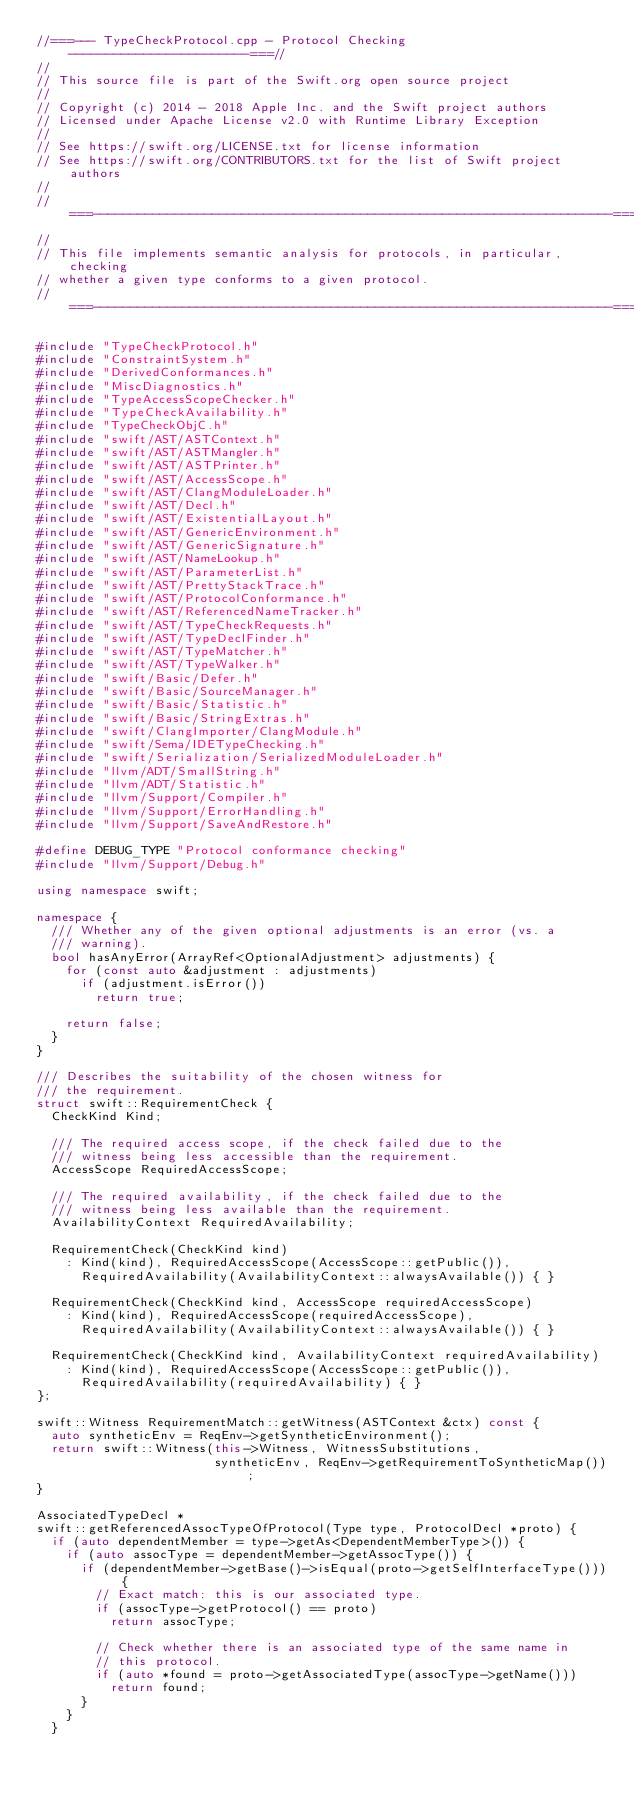<code> <loc_0><loc_0><loc_500><loc_500><_C++_>//===--- TypeCheckProtocol.cpp - Protocol Checking ------------------------===//
//
// This source file is part of the Swift.org open source project
//
// Copyright (c) 2014 - 2018 Apple Inc. and the Swift project authors
// Licensed under Apache License v2.0 with Runtime Library Exception
//
// See https://swift.org/LICENSE.txt for license information
// See https://swift.org/CONTRIBUTORS.txt for the list of Swift project authors
//
//===----------------------------------------------------------------------===//
//
// This file implements semantic analysis for protocols, in particular, checking
// whether a given type conforms to a given protocol.
//===----------------------------------------------------------------------===//

#include "TypeCheckProtocol.h"
#include "ConstraintSystem.h"
#include "DerivedConformances.h"
#include "MiscDiagnostics.h"
#include "TypeAccessScopeChecker.h"
#include "TypeCheckAvailability.h"
#include "TypeCheckObjC.h"
#include "swift/AST/ASTContext.h"
#include "swift/AST/ASTMangler.h"
#include "swift/AST/ASTPrinter.h"
#include "swift/AST/AccessScope.h"
#include "swift/AST/ClangModuleLoader.h"
#include "swift/AST/Decl.h"
#include "swift/AST/ExistentialLayout.h"
#include "swift/AST/GenericEnvironment.h"
#include "swift/AST/GenericSignature.h"
#include "swift/AST/NameLookup.h"
#include "swift/AST/ParameterList.h"
#include "swift/AST/PrettyStackTrace.h"
#include "swift/AST/ProtocolConformance.h"
#include "swift/AST/ReferencedNameTracker.h"
#include "swift/AST/TypeCheckRequests.h"
#include "swift/AST/TypeDeclFinder.h"
#include "swift/AST/TypeMatcher.h"
#include "swift/AST/TypeWalker.h"
#include "swift/Basic/Defer.h"
#include "swift/Basic/SourceManager.h"
#include "swift/Basic/Statistic.h"
#include "swift/Basic/StringExtras.h"
#include "swift/ClangImporter/ClangModule.h"
#include "swift/Sema/IDETypeChecking.h"
#include "swift/Serialization/SerializedModuleLoader.h"
#include "llvm/ADT/SmallString.h"
#include "llvm/ADT/Statistic.h"
#include "llvm/Support/Compiler.h"
#include "llvm/Support/ErrorHandling.h"
#include "llvm/Support/SaveAndRestore.h"

#define DEBUG_TYPE "Protocol conformance checking"
#include "llvm/Support/Debug.h"

using namespace swift;

namespace {
  /// Whether any of the given optional adjustments is an error (vs. a
  /// warning).
  bool hasAnyError(ArrayRef<OptionalAdjustment> adjustments) {
    for (const auto &adjustment : adjustments)
      if (adjustment.isError())
        return true;

    return false;
  }
}

/// Describes the suitability of the chosen witness for
/// the requirement.
struct swift::RequirementCheck {
  CheckKind Kind;

  /// The required access scope, if the check failed due to the
  /// witness being less accessible than the requirement.
  AccessScope RequiredAccessScope;

  /// The required availability, if the check failed due to the
  /// witness being less available than the requirement.
  AvailabilityContext RequiredAvailability;

  RequirementCheck(CheckKind kind)
    : Kind(kind), RequiredAccessScope(AccessScope::getPublic()),
      RequiredAvailability(AvailabilityContext::alwaysAvailable()) { }

  RequirementCheck(CheckKind kind, AccessScope requiredAccessScope)
    : Kind(kind), RequiredAccessScope(requiredAccessScope),
      RequiredAvailability(AvailabilityContext::alwaysAvailable()) { }

  RequirementCheck(CheckKind kind, AvailabilityContext requiredAvailability)
    : Kind(kind), RequiredAccessScope(AccessScope::getPublic()),
      RequiredAvailability(requiredAvailability) { }
};

swift::Witness RequirementMatch::getWitness(ASTContext &ctx) const {
  auto syntheticEnv = ReqEnv->getSyntheticEnvironment();
  return swift::Witness(this->Witness, WitnessSubstitutions,
                        syntheticEnv, ReqEnv->getRequirementToSyntheticMap());
}

AssociatedTypeDecl *
swift::getReferencedAssocTypeOfProtocol(Type type, ProtocolDecl *proto) {
  if (auto dependentMember = type->getAs<DependentMemberType>()) {
    if (auto assocType = dependentMember->getAssocType()) {
      if (dependentMember->getBase()->isEqual(proto->getSelfInterfaceType())) {
        // Exact match: this is our associated type.
        if (assocType->getProtocol() == proto)
          return assocType;

        // Check whether there is an associated type of the same name in
        // this protocol.
        if (auto *found = proto->getAssociatedType(assocType->getName()))
          return found;
      }
    }
  }
</code> 